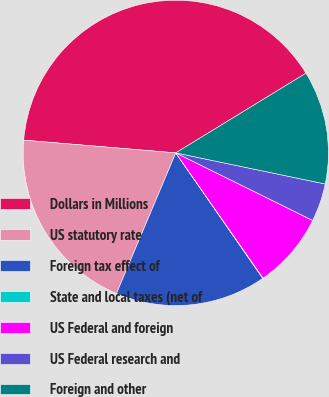<chart> <loc_0><loc_0><loc_500><loc_500><pie_chart><fcel>Dollars in Millions<fcel>US statutory rate<fcel>Foreign tax effect of<fcel>State and local taxes (net of<fcel>US Federal and foreign<fcel>US Federal research and<fcel>Foreign and other<nl><fcel>39.93%<fcel>19.98%<fcel>16.0%<fcel>0.04%<fcel>8.02%<fcel>4.03%<fcel>12.01%<nl></chart> 